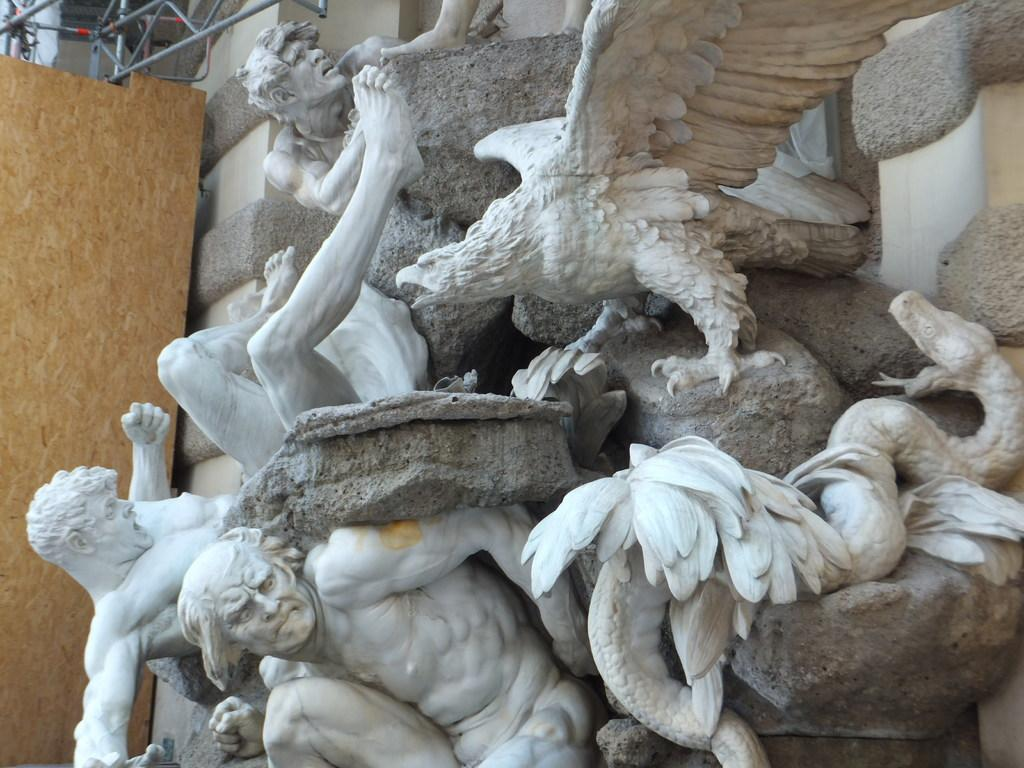What type of artwork can be seen in the image? There are sculptures in the image. What other object is present in the image? There is an iron grill in the image. What type of cheese is being used to create the sculptures in the image? There is no cheese present in the image; the sculptures are not made of cheese. Can you see a hen in the image? There is no hen present in the image. 